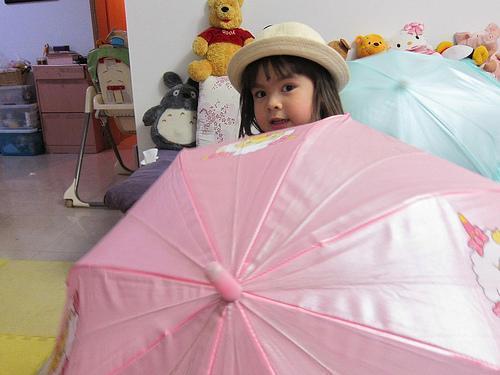How many umbrellas are shown?
Give a very brief answer. 2. How many umbrellas are in the scene?
Give a very brief answer. 2. How many plush animals in the background are white?
Give a very brief answer. 1. 